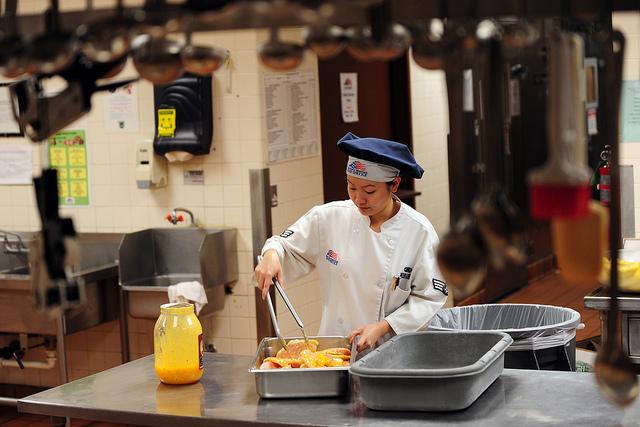What is on the women's heads?
Short answer required. Hat. How many people are in this room?
Keep it brief. 1. Is there a sink?
Concise answer only. Yes. Is the chef wearing a hat?
Quick response, please. Yes. What is the dish hanging across the top of the photo?
Keep it brief. Ladles. What common fixture cover does this hat look like?
Answer briefly. Lid. 